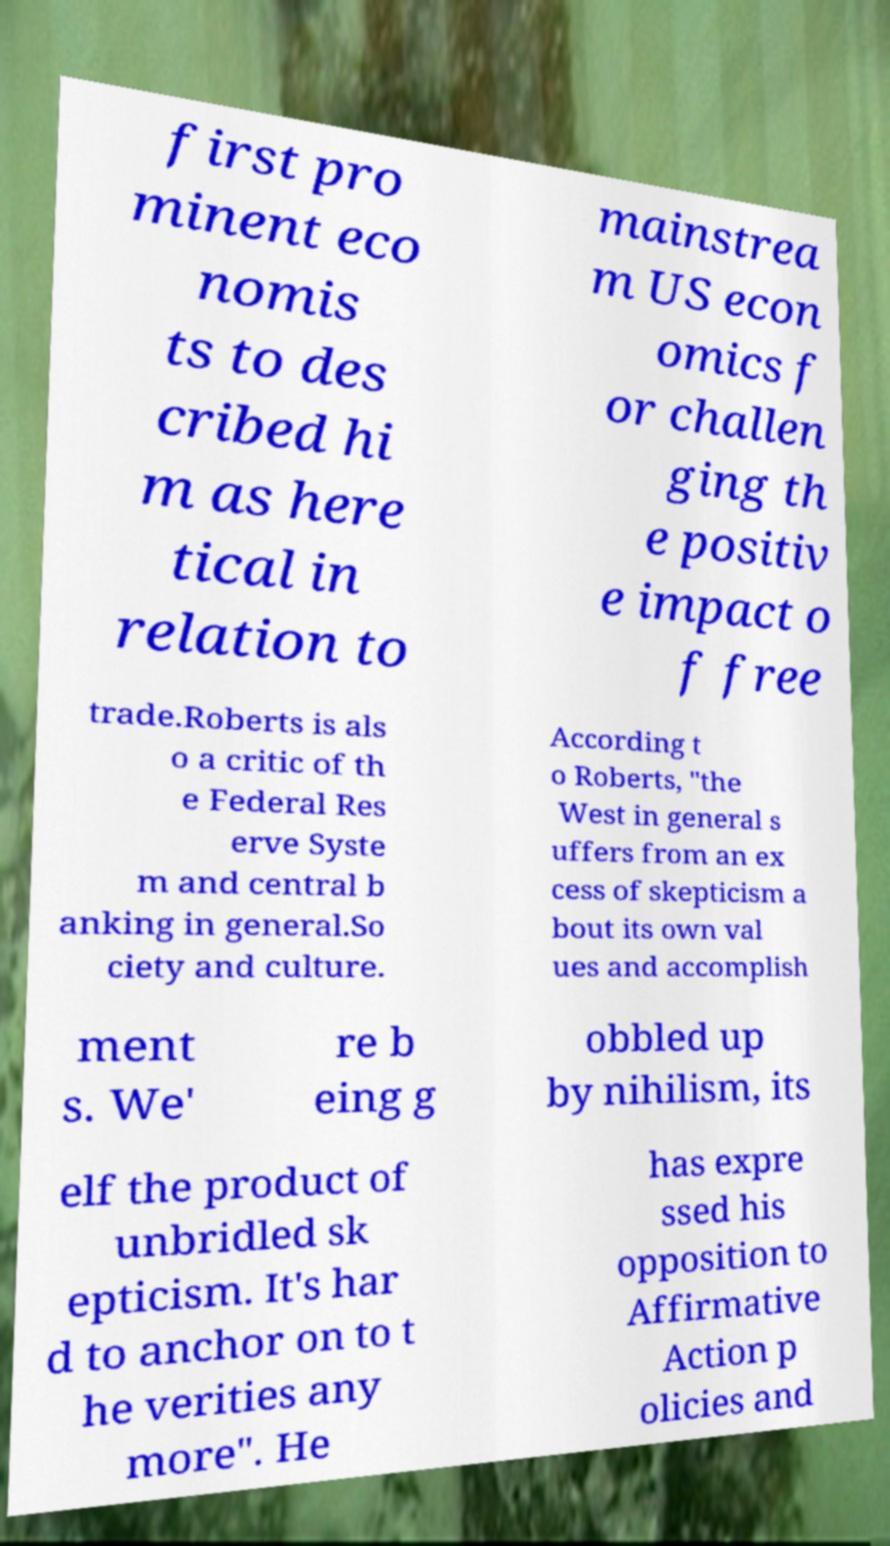Can you accurately transcribe the text from the provided image for me? first pro minent eco nomis ts to des cribed hi m as here tical in relation to mainstrea m US econ omics f or challen ging th e positiv e impact o f free trade.Roberts is als o a critic of th e Federal Res erve Syste m and central b anking in general.So ciety and culture. According t o Roberts, "the West in general s uffers from an ex cess of skepticism a bout its own val ues and accomplish ment s. We' re b eing g obbled up by nihilism, its elf the product of unbridled sk epticism. It's har d to anchor on to t he verities any more". He has expre ssed his opposition to Affirmative Action p olicies and 